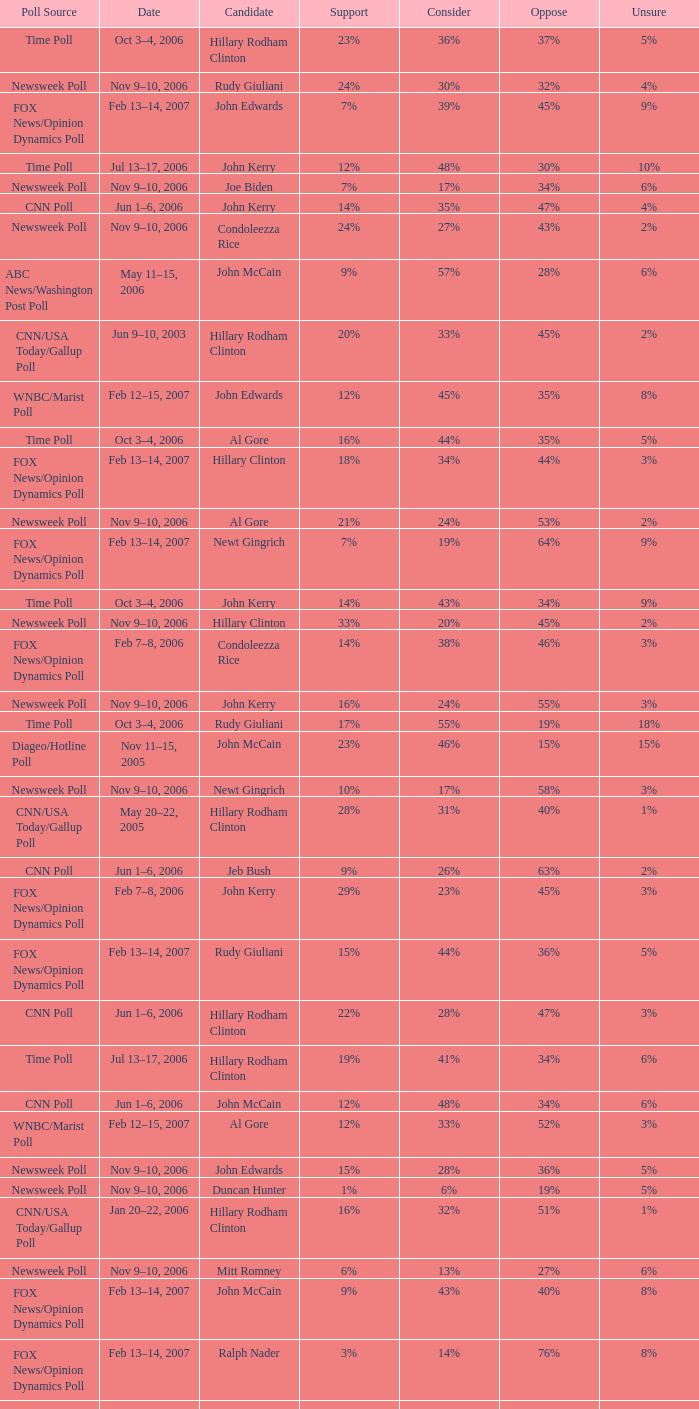What percentage of people were opposed to the candidate based on the WNBC/Marist poll that showed 8% of people were unsure? 35%. 